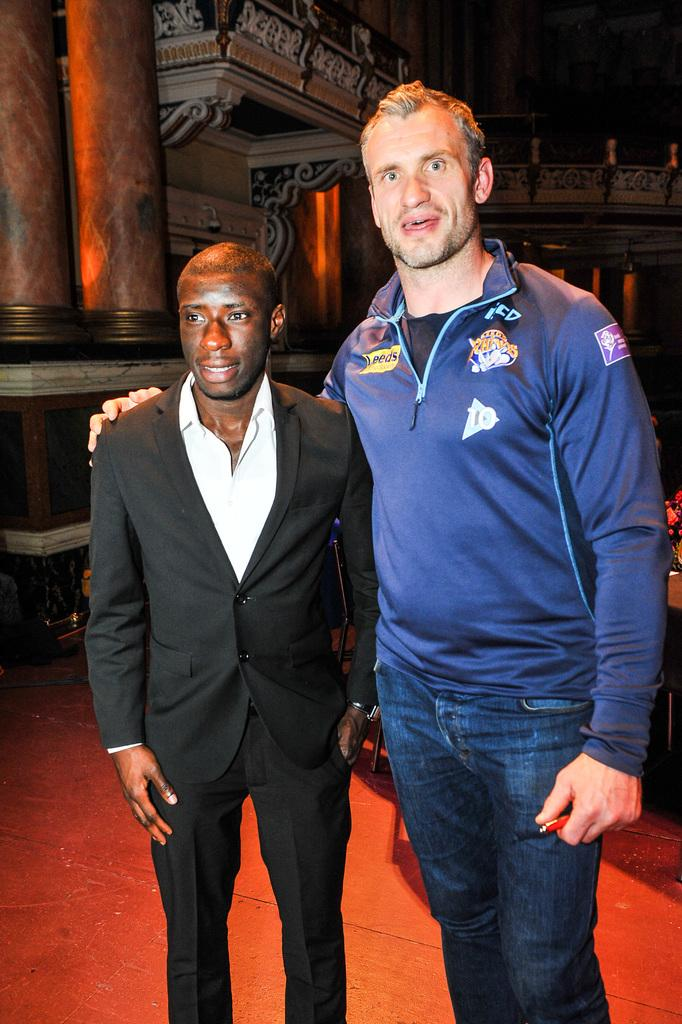How many people are in the image? There are two men in the image. Where is the man on the left side of the image located? The man on the left side is located on the left side of the image. What is the man on the left side wearing? The man on the left side is wearing a suit. What can be seen in the background of the image? There are two pillars in the background of the image. What is the man's aunt doing in the image? There is no mention of an aunt in the image, so it is not possible to answer that question. 